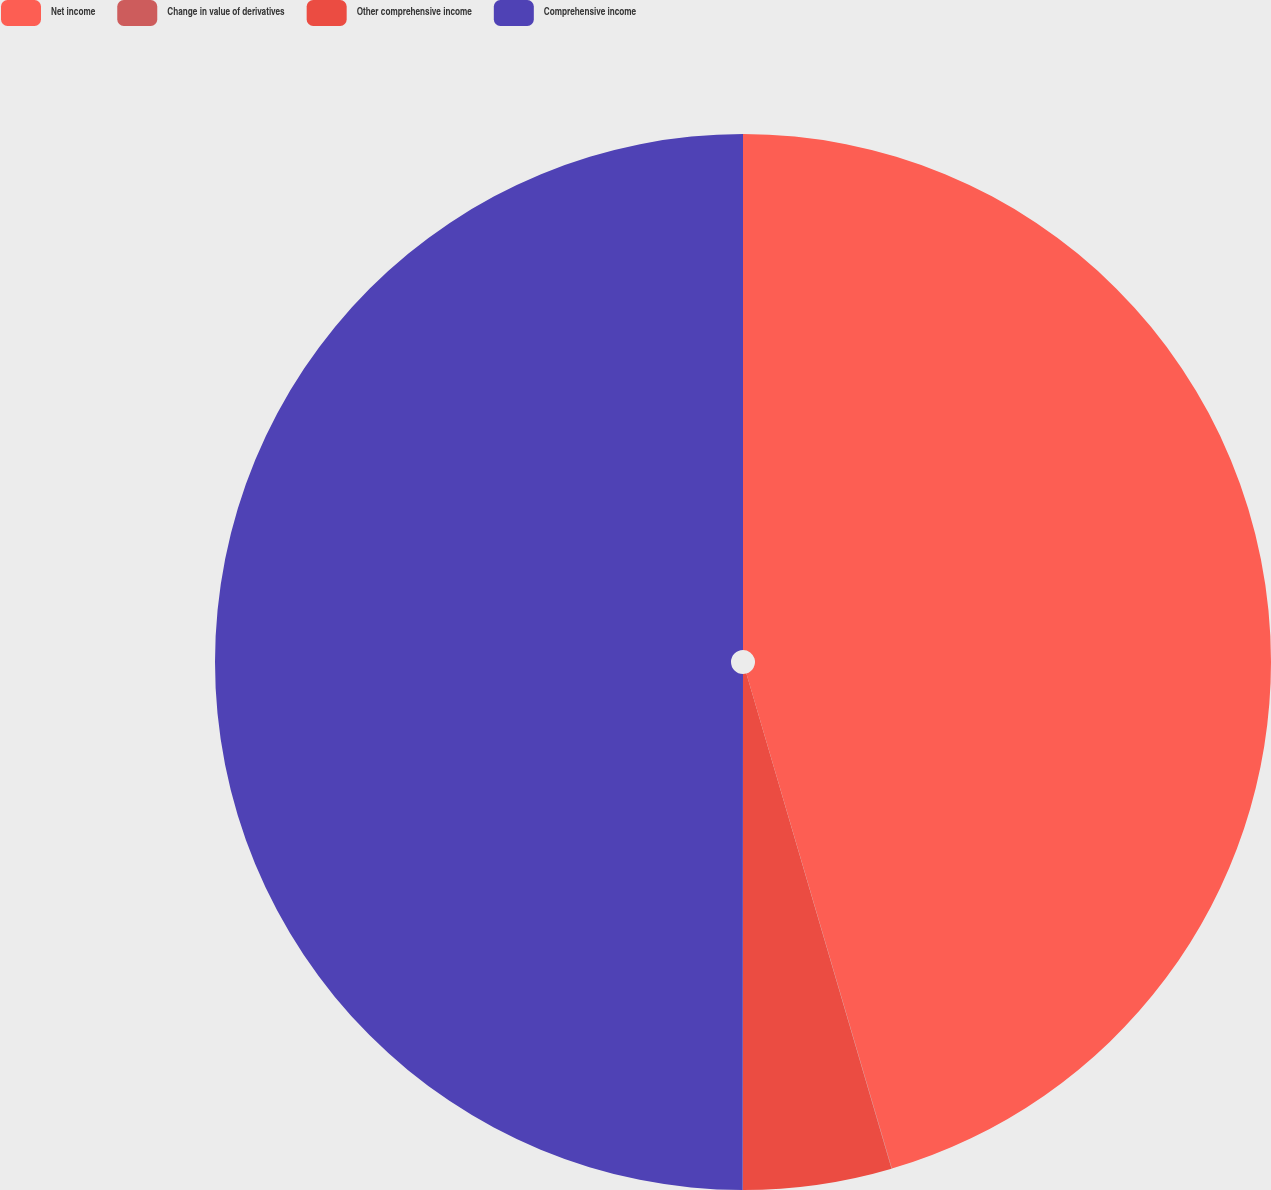Convert chart to OTSL. <chart><loc_0><loc_0><loc_500><loc_500><pie_chart><fcel>Net income<fcel>Change in value of derivatives<fcel>Other comprehensive income<fcel>Comprehensive income<nl><fcel>45.45%<fcel>0.01%<fcel>4.55%<fcel>49.99%<nl></chart> 